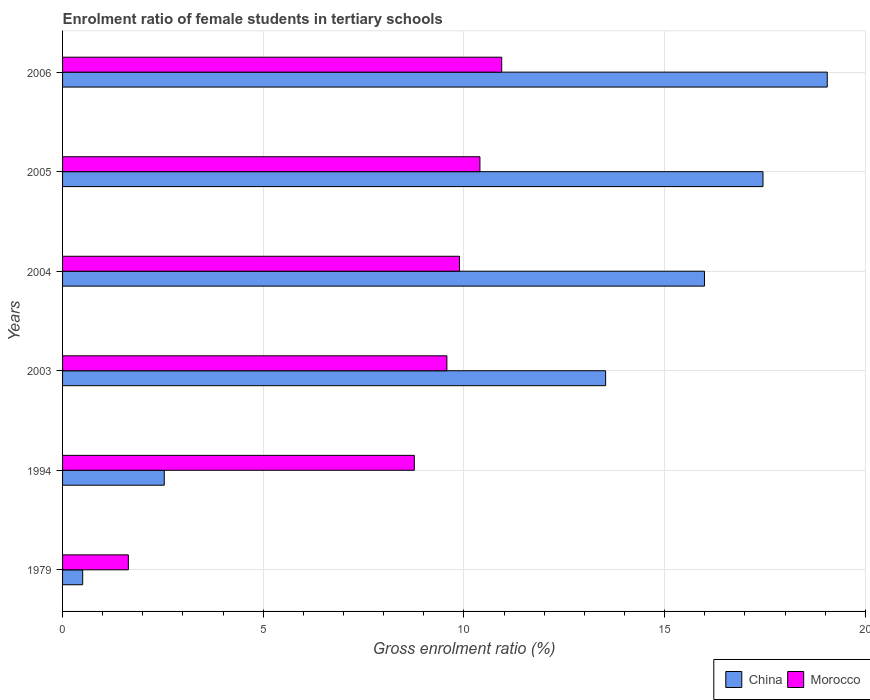How many groups of bars are there?
Offer a terse response. 6. How many bars are there on the 6th tick from the top?
Ensure brevity in your answer.  2. How many bars are there on the 4th tick from the bottom?
Give a very brief answer. 2. What is the label of the 6th group of bars from the top?
Offer a very short reply. 1979. In how many cases, is the number of bars for a given year not equal to the number of legend labels?
Your answer should be very brief. 0. What is the enrolment ratio of female students in tertiary schools in China in 1994?
Offer a very short reply. 2.53. Across all years, what is the maximum enrolment ratio of female students in tertiary schools in China?
Ensure brevity in your answer.  19.05. Across all years, what is the minimum enrolment ratio of female students in tertiary schools in China?
Provide a succinct answer. 0.5. In which year was the enrolment ratio of female students in tertiary schools in China minimum?
Your answer should be very brief. 1979. What is the total enrolment ratio of female students in tertiary schools in Morocco in the graph?
Offer a terse response. 51.2. What is the difference between the enrolment ratio of female students in tertiary schools in China in 1994 and that in 2006?
Give a very brief answer. -16.52. What is the difference between the enrolment ratio of female students in tertiary schools in China in 2006 and the enrolment ratio of female students in tertiary schools in Morocco in 1994?
Offer a very short reply. 10.29. What is the average enrolment ratio of female students in tertiary schools in Morocco per year?
Your answer should be very brief. 8.53. In the year 2003, what is the difference between the enrolment ratio of female students in tertiary schools in China and enrolment ratio of female students in tertiary schools in Morocco?
Your answer should be very brief. 3.95. In how many years, is the enrolment ratio of female students in tertiary schools in Morocco greater than 2 %?
Keep it short and to the point. 5. What is the ratio of the enrolment ratio of female students in tertiary schools in Morocco in 1979 to that in 2004?
Provide a succinct answer. 0.17. Is the difference between the enrolment ratio of female students in tertiary schools in China in 1994 and 2006 greater than the difference between the enrolment ratio of female students in tertiary schools in Morocco in 1994 and 2006?
Ensure brevity in your answer.  No. What is the difference between the highest and the second highest enrolment ratio of female students in tertiary schools in Morocco?
Your response must be concise. 0.54. What is the difference between the highest and the lowest enrolment ratio of female students in tertiary schools in Morocco?
Make the answer very short. 9.3. In how many years, is the enrolment ratio of female students in tertiary schools in China greater than the average enrolment ratio of female students in tertiary schools in China taken over all years?
Provide a short and direct response. 4. What does the 1st bar from the top in 1979 represents?
Your response must be concise. Morocco. How many bars are there?
Your response must be concise. 12. What is the difference between two consecutive major ticks on the X-axis?
Provide a succinct answer. 5. Does the graph contain any zero values?
Keep it short and to the point. No. Does the graph contain grids?
Your response must be concise. Yes. How many legend labels are there?
Provide a short and direct response. 2. How are the legend labels stacked?
Your answer should be compact. Horizontal. What is the title of the graph?
Keep it short and to the point. Enrolment ratio of female students in tertiary schools. Does "Isle of Man" appear as one of the legend labels in the graph?
Your response must be concise. No. What is the Gross enrolment ratio (%) in China in 1979?
Provide a short and direct response. 0.5. What is the Gross enrolment ratio (%) in Morocco in 1979?
Provide a succinct answer. 1.64. What is the Gross enrolment ratio (%) in China in 1994?
Provide a short and direct response. 2.53. What is the Gross enrolment ratio (%) of Morocco in 1994?
Provide a short and direct response. 8.76. What is the Gross enrolment ratio (%) of China in 2003?
Provide a succinct answer. 13.53. What is the Gross enrolment ratio (%) of Morocco in 2003?
Offer a terse response. 9.57. What is the Gross enrolment ratio (%) in China in 2004?
Offer a terse response. 15.99. What is the Gross enrolment ratio (%) of Morocco in 2004?
Provide a short and direct response. 9.89. What is the Gross enrolment ratio (%) of China in 2005?
Make the answer very short. 17.45. What is the Gross enrolment ratio (%) of Morocco in 2005?
Offer a terse response. 10.4. What is the Gross enrolment ratio (%) in China in 2006?
Ensure brevity in your answer.  19.05. What is the Gross enrolment ratio (%) in Morocco in 2006?
Your response must be concise. 10.94. Across all years, what is the maximum Gross enrolment ratio (%) in China?
Provide a short and direct response. 19.05. Across all years, what is the maximum Gross enrolment ratio (%) in Morocco?
Offer a very short reply. 10.94. Across all years, what is the minimum Gross enrolment ratio (%) in China?
Offer a very short reply. 0.5. Across all years, what is the minimum Gross enrolment ratio (%) in Morocco?
Provide a succinct answer. 1.64. What is the total Gross enrolment ratio (%) in China in the graph?
Ensure brevity in your answer.  69.05. What is the total Gross enrolment ratio (%) in Morocco in the graph?
Make the answer very short. 51.2. What is the difference between the Gross enrolment ratio (%) in China in 1979 and that in 1994?
Offer a terse response. -2.03. What is the difference between the Gross enrolment ratio (%) of Morocco in 1979 and that in 1994?
Offer a terse response. -7.12. What is the difference between the Gross enrolment ratio (%) in China in 1979 and that in 2003?
Your response must be concise. -13.03. What is the difference between the Gross enrolment ratio (%) in Morocco in 1979 and that in 2003?
Provide a short and direct response. -7.94. What is the difference between the Gross enrolment ratio (%) in China in 1979 and that in 2004?
Keep it short and to the point. -15.49. What is the difference between the Gross enrolment ratio (%) in Morocco in 1979 and that in 2004?
Keep it short and to the point. -8.25. What is the difference between the Gross enrolment ratio (%) of China in 1979 and that in 2005?
Make the answer very short. -16.95. What is the difference between the Gross enrolment ratio (%) of Morocco in 1979 and that in 2005?
Offer a terse response. -8.76. What is the difference between the Gross enrolment ratio (%) in China in 1979 and that in 2006?
Keep it short and to the point. -18.55. What is the difference between the Gross enrolment ratio (%) of Morocco in 1979 and that in 2006?
Give a very brief answer. -9.3. What is the difference between the Gross enrolment ratio (%) of China in 1994 and that in 2003?
Your response must be concise. -11. What is the difference between the Gross enrolment ratio (%) of Morocco in 1994 and that in 2003?
Give a very brief answer. -0.81. What is the difference between the Gross enrolment ratio (%) of China in 1994 and that in 2004?
Your answer should be very brief. -13.46. What is the difference between the Gross enrolment ratio (%) in Morocco in 1994 and that in 2004?
Give a very brief answer. -1.12. What is the difference between the Gross enrolment ratio (%) of China in 1994 and that in 2005?
Offer a very short reply. -14.92. What is the difference between the Gross enrolment ratio (%) in Morocco in 1994 and that in 2005?
Your response must be concise. -1.63. What is the difference between the Gross enrolment ratio (%) of China in 1994 and that in 2006?
Offer a terse response. -16.52. What is the difference between the Gross enrolment ratio (%) in Morocco in 1994 and that in 2006?
Your answer should be very brief. -2.18. What is the difference between the Gross enrolment ratio (%) in China in 2003 and that in 2004?
Provide a short and direct response. -2.46. What is the difference between the Gross enrolment ratio (%) in Morocco in 2003 and that in 2004?
Offer a very short reply. -0.31. What is the difference between the Gross enrolment ratio (%) of China in 2003 and that in 2005?
Ensure brevity in your answer.  -3.92. What is the difference between the Gross enrolment ratio (%) in Morocco in 2003 and that in 2005?
Make the answer very short. -0.82. What is the difference between the Gross enrolment ratio (%) in China in 2003 and that in 2006?
Your answer should be very brief. -5.52. What is the difference between the Gross enrolment ratio (%) of Morocco in 2003 and that in 2006?
Offer a terse response. -1.37. What is the difference between the Gross enrolment ratio (%) in China in 2004 and that in 2005?
Keep it short and to the point. -1.46. What is the difference between the Gross enrolment ratio (%) in Morocco in 2004 and that in 2005?
Your response must be concise. -0.51. What is the difference between the Gross enrolment ratio (%) of China in 2004 and that in 2006?
Your answer should be very brief. -3.06. What is the difference between the Gross enrolment ratio (%) in Morocco in 2004 and that in 2006?
Make the answer very short. -1.05. What is the difference between the Gross enrolment ratio (%) in China in 2005 and that in 2006?
Your response must be concise. -1.6. What is the difference between the Gross enrolment ratio (%) of Morocco in 2005 and that in 2006?
Your answer should be compact. -0.54. What is the difference between the Gross enrolment ratio (%) of China in 1979 and the Gross enrolment ratio (%) of Morocco in 1994?
Ensure brevity in your answer.  -8.26. What is the difference between the Gross enrolment ratio (%) of China in 1979 and the Gross enrolment ratio (%) of Morocco in 2003?
Your response must be concise. -9.07. What is the difference between the Gross enrolment ratio (%) of China in 1979 and the Gross enrolment ratio (%) of Morocco in 2004?
Provide a succinct answer. -9.39. What is the difference between the Gross enrolment ratio (%) in China in 1979 and the Gross enrolment ratio (%) in Morocco in 2005?
Your response must be concise. -9.9. What is the difference between the Gross enrolment ratio (%) of China in 1979 and the Gross enrolment ratio (%) of Morocco in 2006?
Your answer should be compact. -10.44. What is the difference between the Gross enrolment ratio (%) in China in 1994 and the Gross enrolment ratio (%) in Morocco in 2003?
Provide a short and direct response. -7.04. What is the difference between the Gross enrolment ratio (%) in China in 1994 and the Gross enrolment ratio (%) in Morocco in 2004?
Provide a succinct answer. -7.35. What is the difference between the Gross enrolment ratio (%) in China in 1994 and the Gross enrolment ratio (%) in Morocco in 2005?
Offer a very short reply. -7.86. What is the difference between the Gross enrolment ratio (%) of China in 1994 and the Gross enrolment ratio (%) of Morocco in 2006?
Give a very brief answer. -8.41. What is the difference between the Gross enrolment ratio (%) of China in 2003 and the Gross enrolment ratio (%) of Morocco in 2004?
Ensure brevity in your answer.  3.64. What is the difference between the Gross enrolment ratio (%) in China in 2003 and the Gross enrolment ratio (%) in Morocco in 2005?
Provide a short and direct response. 3.13. What is the difference between the Gross enrolment ratio (%) of China in 2003 and the Gross enrolment ratio (%) of Morocco in 2006?
Provide a short and direct response. 2.59. What is the difference between the Gross enrolment ratio (%) in China in 2004 and the Gross enrolment ratio (%) in Morocco in 2005?
Provide a short and direct response. 5.59. What is the difference between the Gross enrolment ratio (%) of China in 2004 and the Gross enrolment ratio (%) of Morocco in 2006?
Offer a terse response. 5.05. What is the difference between the Gross enrolment ratio (%) of China in 2005 and the Gross enrolment ratio (%) of Morocco in 2006?
Give a very brief answer. 6.51. What is the average Gross enrolment ratio (%) in China per year?
Offer a terse response. 11.51. What is the average Gross enrolment ratio (%) in Morocco per year?
Your response must be concise. 8.53. In the year 1979, what is the difference between the Gross enrolment ratio (%) in China and Gross enrolment ratio (%) in Morocco?
Offer a terse response. -1.14. In the year 1994, what is the difference between the Gross enrolment ratio (%) of China and Gross enrolment ratio (%) of Morocco?
Provide a short and direct response. -6.23. In the year 2003, what is the difference between the Gross enrolment ratio (%) in China and Gross enrolment ratio (%) in Morocco?
Give a very brief answer. 3.95. In the year 2004, what is the difference between the Gross enrolment ratio (%) of China and Gross enrolment ratio (%) of Morocco?
Ensure brevity in your answer.  6.1. In the year 2005, what is the difference between the Gross enrolment ratio (%) of China and Gross enrolment ratio (%) of Morocco?
Ensure brevity in your answer.  7.05. In the year 2006, what is the difference between the Gross enrolment ratio (%) of China and Gross enrolment ratio (%) of Morocco?
Provide a succinct answer. 8.11. What is the ratio of the Gross enrolment ratio (%) in China in 1979 to that in 1994?
Your answer should be compact. 0.2. What is the ratio of the Gross enrolment ratio (%) in Morocco in 1979 to that in 1994?
Your answer should be very brief. 0.19. What is the ratio of the Gross enrolment ratio (%) in China in 1979 to that in 2003?
Offer a terse response. 0.04. What is the ratio of the Gross enrolment ratio (%) in Morocco in 1979 to that in 2003?
Your answer should be very brief. 0.17. What is the ratio of the Gross enrolment ratio (%) in China in 1979 to that in 2004?
Offer a terse response. 0.03. What is the ratio of the Gross enrolment ratio (%) of Morocco in 1979 to that in 2004?
Your response must be concise. 0.17. What is the ratio of the Gross enrolment ratio (%) in China in 1979 to that in 2005?
Ensure brevity in your answer.  0.03. What is the ratio of the Gross enrolment ratio (%) in Morocco in 1979 to that in 2005?
Provide a short and direct response. 0.16. What is the ratio of the Gross enrolment ratio (%) of China in 1979 to that in 2006?
Offer a very short reply. 0.03. What is the ratio of the Gross enrolment ratio (%) in Morocco in 1979 to that in 2006?
Offer a very short reply. 0.15. What is the ratio of the Gross enrolment ratio (%) in China in 1994 to that in 2003?
Provide a succinct answer. 0.19. What is the ratio of the Gross enrolment ratio (%) in Morocco in 1994 to that in 2003?
Your answer should be very brief. 0.92. What is the ratio of the Gross enrolment ratio (%) in China in 1994 to that in 2004?
Make the answer very short. 0.16. What is the ratio of the Gross enrolment ratio (%) in Morocco in 1994 to that in 2004?
Offer a very short reply. 0.89. What is the ratio of the Gross enrolment ratio (%) of China in 1994 to that in 2005?
Keep it short and to the point. 0.15. What is the ratio of the Gross enrolment ratio (%) of Morocco in 1994 to that in 2005?
Your answer should be very brief. 0.84. What is the ratio of the Gross enrolment ratio (%) of China in 1994 to that in 2006?
Give a very brief answer. 0.13. What is the ratio of the Gross enrolment ratio (%) of Morocco in 1994 to that in 2006?
Make the answer very short. 0.8. What is the ratio of the Gross enrolment ratio (%) of China in 2003 to that in 2004?
Keep it short and to the point. 0.85. What is the ratio of the Gross enrolment ratio (%) of Morocco in 2003 to that in 2004?
Make the answer very short. 0.97. What is the ratio of the Gross enrolment ratio (%) of China in 2003 to that in 2005?
Ensure brevity in your answer.  0.78. What is the ratio of the Gross enrolment ratio (%) of Morocco in 2003 to that in 2005?
Provide a short and direct response. 0.92. What is the ratio of the Gross enrolment ratio (%) of China in 2003 to that in 2006?
Your response must be concise. 0.71. What is the ratio of the Gross enrolment ratio (%) in Morocco in 2003 to that in 2006?
Provide a short and direct response. 0.88. What is the ratio of the Gross enrolment ratio (%) of China in 2004 to that in 2005?
Give a very brief answer. 0.92. What is the ratio of the Gross enrolment ratio (%) in Morocco in 2004 to that in 2005?
Offer a terse response. 0.95. What is the ratio of the Gross enrolment ratio (%) of China in 2004 to that in 2006?
Your response must be concise. 0.84. What is the ratio of the Gross enrolment ratio (%) in Morocco in 2004 to that in 2006?
Your answer should be compact. 0.9. What is the ratio of the Gross enrolment ratio (%) of China in 2005 to that in 2006?
Your answer should be very brief. 0.92. What is the ratio of the Gross enrolment ratio (%) in Morocco in 2005 to that in 2006?
Keep it short and to the point. 0.95. What is the difference between the highest and the second highest Gross enrolment ratio (%) in China?
Keep it short and to the point. 1.6. What is the difference between the highest and the second highest Gross enrolment ratio (%) of Morocco?
Provide a short and direct response. 0.54. What is the difference between the highest and the lowest Gross enrolment ratio (%) of China?
Offer a terse response. 18.55. What is the difference between the highest and the lowest Gross enrolment ratio (%) in Morocco?
Your answer should be very brief. 9.3. 